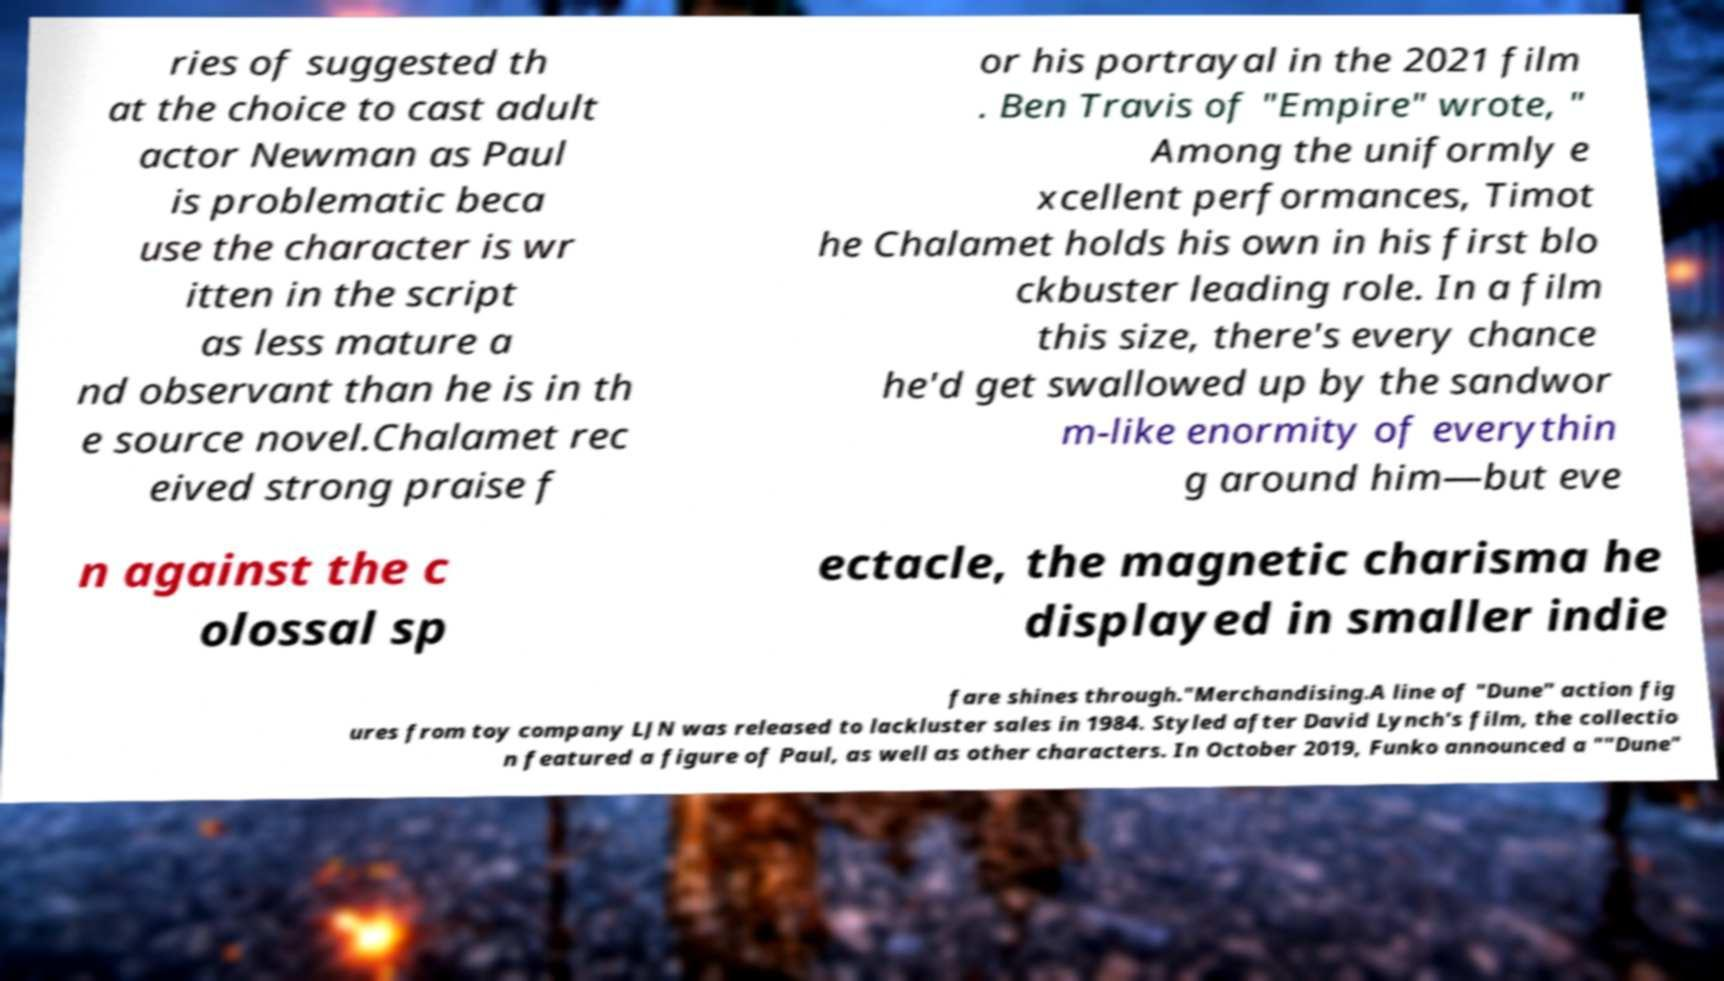Please identify and transcribe the text found in this image. ries of suggested th at the choice to cast adult actor Newman as Paul is problematic beca use the character is wr itten in the script as less mature a nd observant than he is in th e source novel.Chalamet rec eived strong praise f or his portrayal in the 2021 film . Ben Travis of "Empire" wrote, " Among the uniformly e xcellent performances, Timot he Chalamet holds his own in his first blo ckbuster leading role. In a film this size, there's every chance he'd get swallowed up by the sandwor m-like enormity of everythin g around him—but eve n against the c olossal sp ectacle, the magnetic charisma he displayed in smaller indie fare shines through."Merchandising.A line of "Dune" action fig ures from toy company LJN was released to lackluster sales in 1984. Styled after David Lynch's film, the collectio n featured a figure of Paul, as well as other characters. In October 2019, Funko announced a ""Dune" 